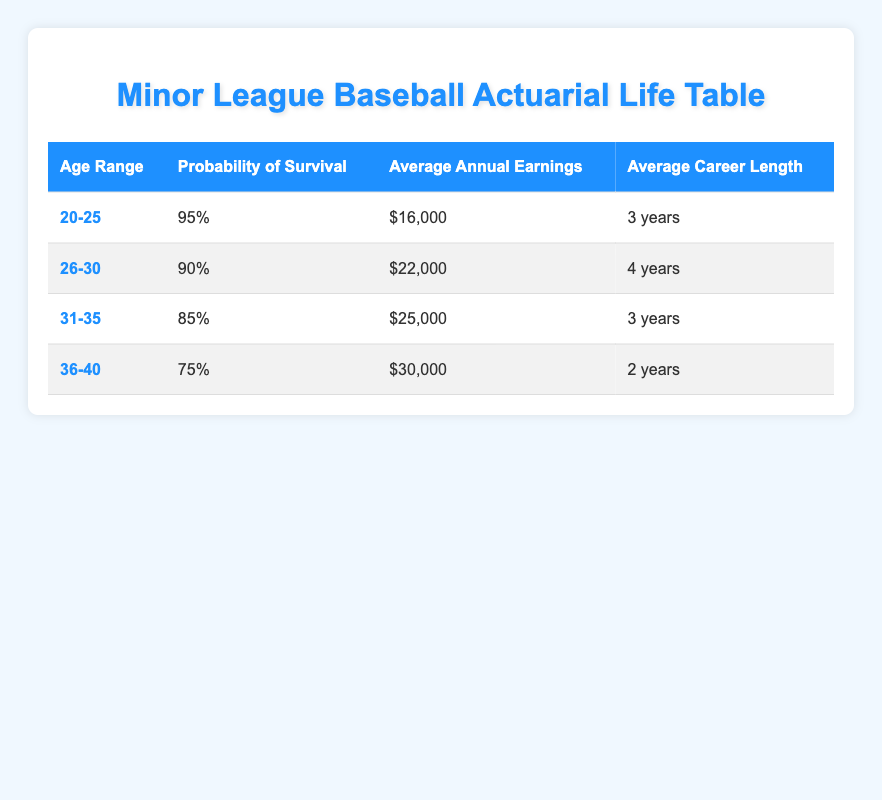What is the total average annual earnings for players aged 20-25? The average annual earnings for players aged 20-25 is $16,000. Since there is only one age range to consider, there is no need to sum or average multiple values.
Answer: 16000 What is the probability of survival for players aged 26-30? According to the table, the probability of survival for players in the age range of 26-30 is shown as 90%. This information is directly found in the corresponding column for that age range.
Answer: 90% Which age range has the highest average annual earnings? To determine which age range has the highest average annual earnings, we look at the values: 20-25 has $16,000, 26-30 has $22,000, 31-35 has $25,000, and 36-40 has $30,000. The highest is $30,000 for the age range of 36-40.
Answer: 36-40 What is the average career length for players aged 31-35? The table specifies that the average career length for players aged 31-35 is 3 years. This can be directly found in the average career length column for that age range.
Answer: 3 years Is the average annual earnings for players aged 36-40 higher than for players aged 26-30? No, the average annual earnings for players aged 36-40 is $30,000 while for players aged 26-30 it is $22,000. Since $30,000 is greater than $22,000, the earnings for 36-40 are higher, making this statement false.
Answer: No What is the total average career length for players aged 20-25 and 26-30 combined? The average career lengths for the age ranges are 3 years for 20-25 and 4 years for 26-30. To find the total average career length, sum these two values (3 + 4) and divide by 2, which gives (7/2) = 3.5 years.
Answer: 3.5 years What is the average annual earnings difference between age ranges 31-35 and 26-30? The average annual earnings for age range 31-35 is $25,000 and for 26-30 is $22,000. The difference is calculated by subtracting the lower value from the higher: $25,000 - $22,000 = $3,000.
Answer: 3000 Do players aged 20-25 have a longer average career length than those aged 36-40? Yes, players aged 20-25 have an average career length of 3 years, while those aged 36-40 have an average career length of 2 years. Since 3 years is greater than 2 years, the statement is true.
Answer: Yes 